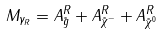Convert formula to latex. <formula><loc_0><loc_0><loc_500><loc_500>M _ { \gamma _ { R } } = A _ { \tilde { g } } ^ { R } + A _ { \tilde { \chi } ^ { - } } ^ { R } + A _ { \tilde { \chi } ^ { 0 } } ^ { R }</formula> 